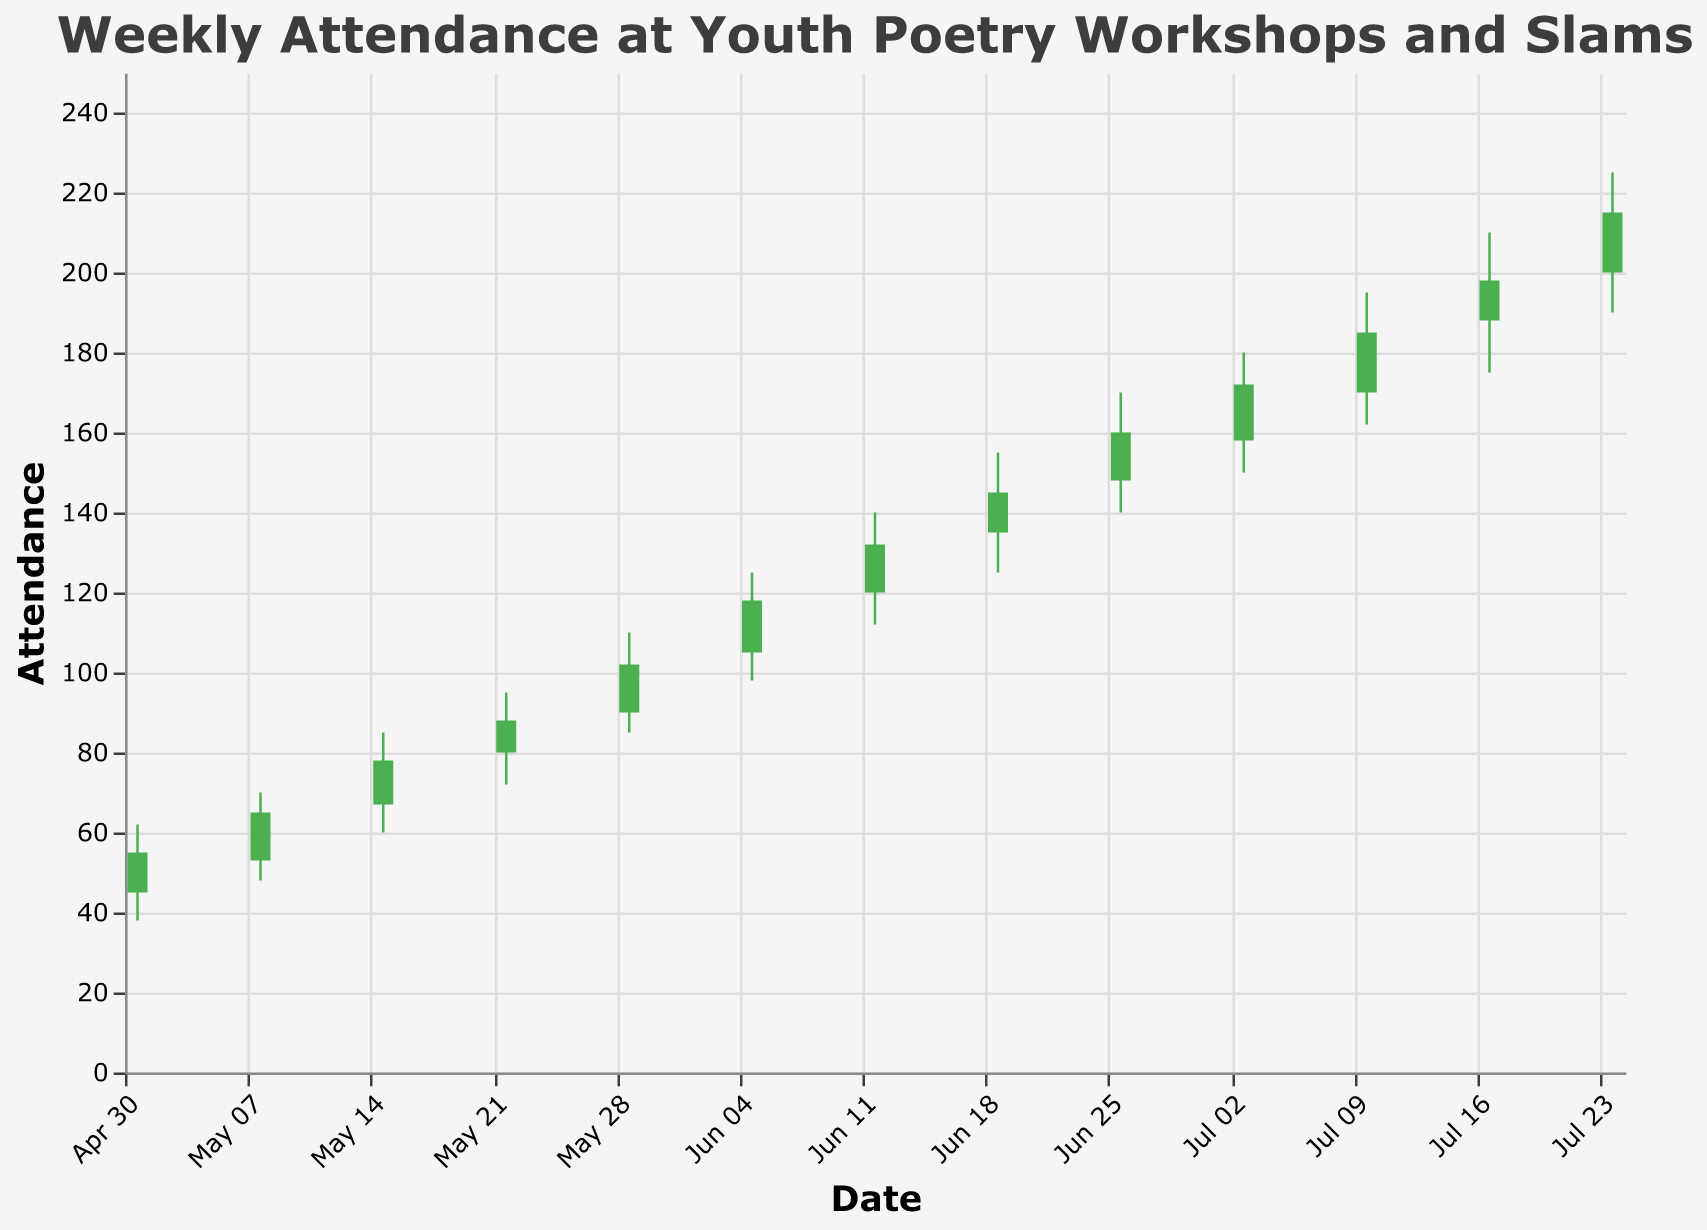What is the title of the figure? The title is displayed prominently at the top of the figure. It reads "Weekly Attendance at Youth Poetry Workshops and Slams," which is the primary subject of the data visualization.
Answer: Weekly Attendance at Youth Poetry Workshops and Slams How many weeks are represented in the figure? To find the number of weeks, count the number of distinct dates on the x-axis.
Answer: 13 What is the highest attendance recorded and when did it occur? The highest attendance is represented by the highest 'High' value on the y-axis, which is 225. This value corresponds to the date labeled July 24, 2023.
Answer: 225, July 24, 2023 Which week saw the lowest attendance and what was that value? The lowest attendance can be identified by looking at the lowest 'Low' value on the y-axis, which is 38, corresponding to the week of May 1, 2023.
Answer: 38, May 1, 2023 Did attendance increase or decrease between the week of June 12 and June 19? Compare the 'Close' value of June 12 (132) with the 'Open' value of June 19 (135). Attendance increased if June 19's open value is higher than June 12's close value.
Answer: Increased Which week had the most significant difference between the highest and lowest attendance? For each week, subtract the 'Low' value from the 'High' value and compare. The week with the greatest difference is the week of July 24, with a difference of 225 - 190 = 35.
Answer: July 24 What were the open and close attendance values on July 3, 2023? Look at the data for July 3. The 'Open' value is 158, and the 'Close' value is 172.
Answer: 158 (Open), 172 (Close) By how much did the attendance close on July 17 exceed the open attendance on June 5? The 'Close' value for July 17 is 198, and the 'Open' value for June 5 is 105. Subtract to find the difference: 198 - 105 = 93.
Answer: 93 Which weeks exhibit an increase in attendance from opening to closing? For each week, check if the 'Close' value is higher than the 'Open' value. Such weeks have attendance bars colored in green. These weeks are: May 1, May 8, May 15, May 22, May 29, June 5, June 12, June 19, June 26, July 3, July 10, July 17, and July 24.
Answer: May 1, May 8, May 15, May 22, May 29, June 5, June 12, June 19, June 26, July 3, July 10, July 17, July 24 